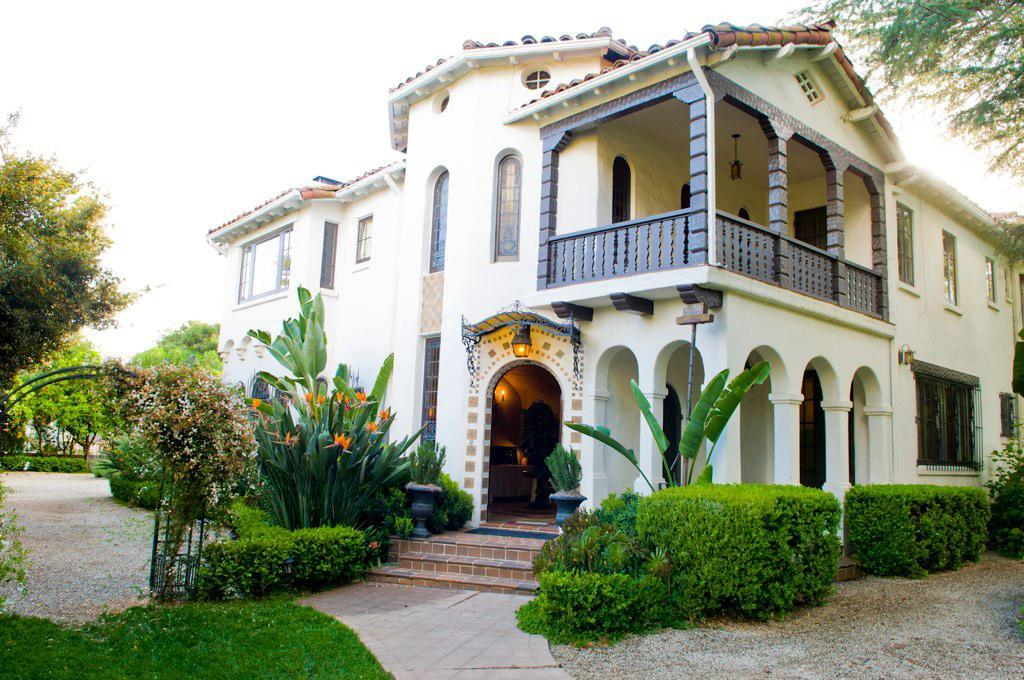What type of vegetation can be seen in the image? There is grass in the image, as well as plants and trees. What kind of walkway is present in the image? There is a path in the image. Are there any containers for plants in the image? Yes, there are pots in the image. Can you describe the architectural feature in the image? There are steps in the image, and there is a building with windows. What additional objects can be seen in the image? There are some objects in the image, but their specific nature is not mentioned. What can be seen in the background of the image? The sky is visible in the background of the image. What is the weight of the order in the image? There is no order present in the image, so it is not possible to determine its weight. 